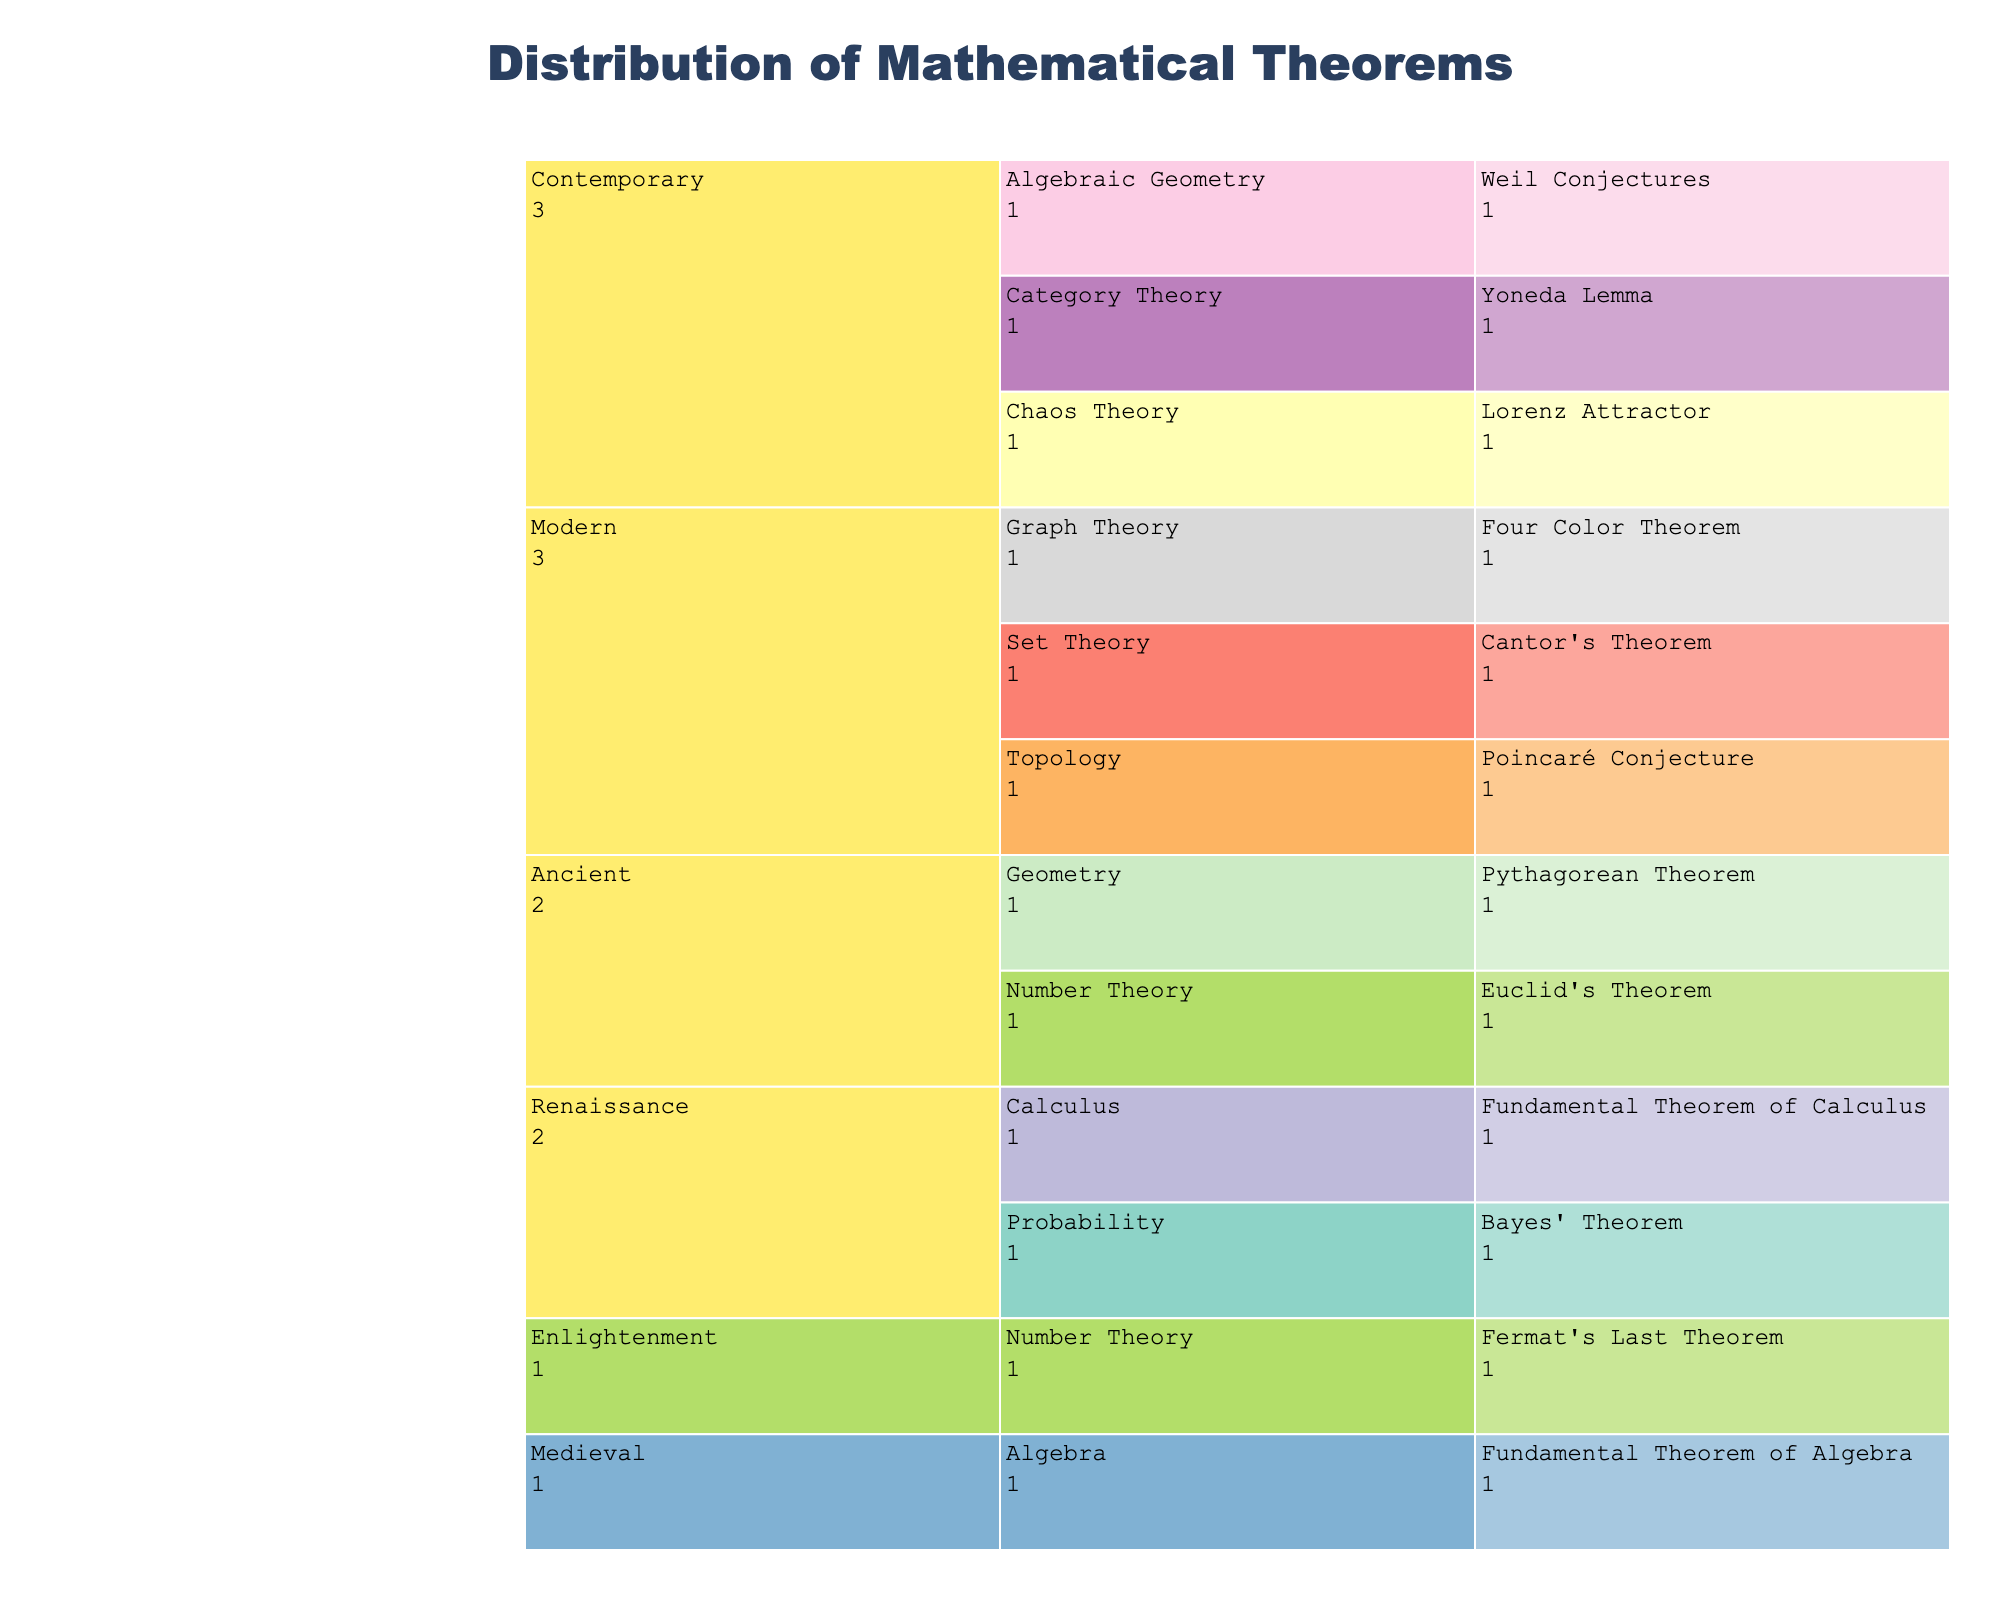What is the title of the icicle chart? The title is displayed at the top of the chart and is a key starting point to understand its context.
Answer: Distribution of Mathematical Theorems Which historical era has the most mathematical fields represented? To answer this, look at the icicle chart and count the number of fields under each era.
Answer: Modern How many theorems are categorized under the Field of Algebra? By tracing the branches under the Algebra field, you can count the specific number of theorems listed.
Answer: 1 Which theorem from the Contemporary era is applied in Weather Prediction? Look under the Contemporary era, find the field associated with Weather Prediction, and identify the corresponding theorem.
Answer: Lorenz Attractor Compare the number of theorems in the Modern era and the Enlightenment era. Which has more and by how many? Count the number of theorems under both the Enlightenment and Modern eras, and then subtract the count of the Enlightenment from the Modern.
Answer: Modern has 3 more theorems Of all the different practical applications, which one is associated with more than one theorem in different eras? Identify which applications appear multiple times across different eras.
Answer: Cryptography Among the Ancient era theorems, which fields do they belong to and what are their practical applications? Review the theorems listed under the Ancient era, note their respective fields, and their practical applications.
Answer: Geometry (Architecture), Number Theory (Cryptography) Which field in the Renaissance era includes a theorem applied in Physics? Locate the Renaissance era and within it, identify the field that has a theorem applied in Physics.
Answer: Calculus How many theorems are rooted in applications related to Cryptography? Search through all the eras and count the instances where Cryptography is listed as the practical application.
Answer: 2 What field and practical application does Cantor's Theorem belong to? Find Cantor's Theorem in the icicle chart and note the field and practical application associated with it.
Answer: Set Theory, Foundations of Mathematics 